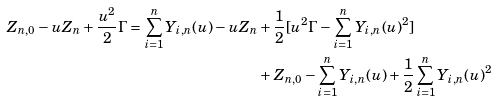<formula> <loc_0><loc_0><loc_500><loc_500>Z _ { n , 0 } - u Z _ { n } + \frac { u ^ { 2 } } { 2 } \Gamma = \sum _ { i = 1 } ^ { n } Y _ { i , n } ( u ) - u Z _ { n } & + \frac { 1 } { 2 } [ u ^ { 2 } \Gamma - \sum _ { i = 1 } ^ { n } Y _ { i , n } ( u ) ^ { 2 } ] \\ & + Z _ { n , 0 } - \sum _ { i = 1 } ^ { n } Y _ { i , n } ( u ) + \frac { 1 } { 2 } \sum _ { i = 1 } ^ { n } Y _ { i , n } ( u ) ^ { 2 }</formula> 